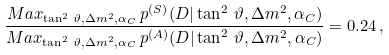Convert formula to latex. <formula><loc_0><loc_0><loc_500><loc_500>\frac { M a x _ { \tan ^ { 2 } \, \vartheta , \Delta { m } ^ { 2 } , \alpha _ { C } } \, p ^ { ( S ) } ( D | \tan ^ { 2 } \, \vartheta , \Delta { m } ^ { 2 } , \alpha _ { C } ) } { M a x _ { \tan ^ { 2 } \, \vartheta , \Delta { m } ^ { 2 } , \alpha _ { C } } \, p ^ { ( A ) } ( D | \tan ^ { 2 } \, \vartheta , \Delta { m } ^ { 2 } , \alpha _ { C } ) } = 0 . 2 4 \, ,</formula> 